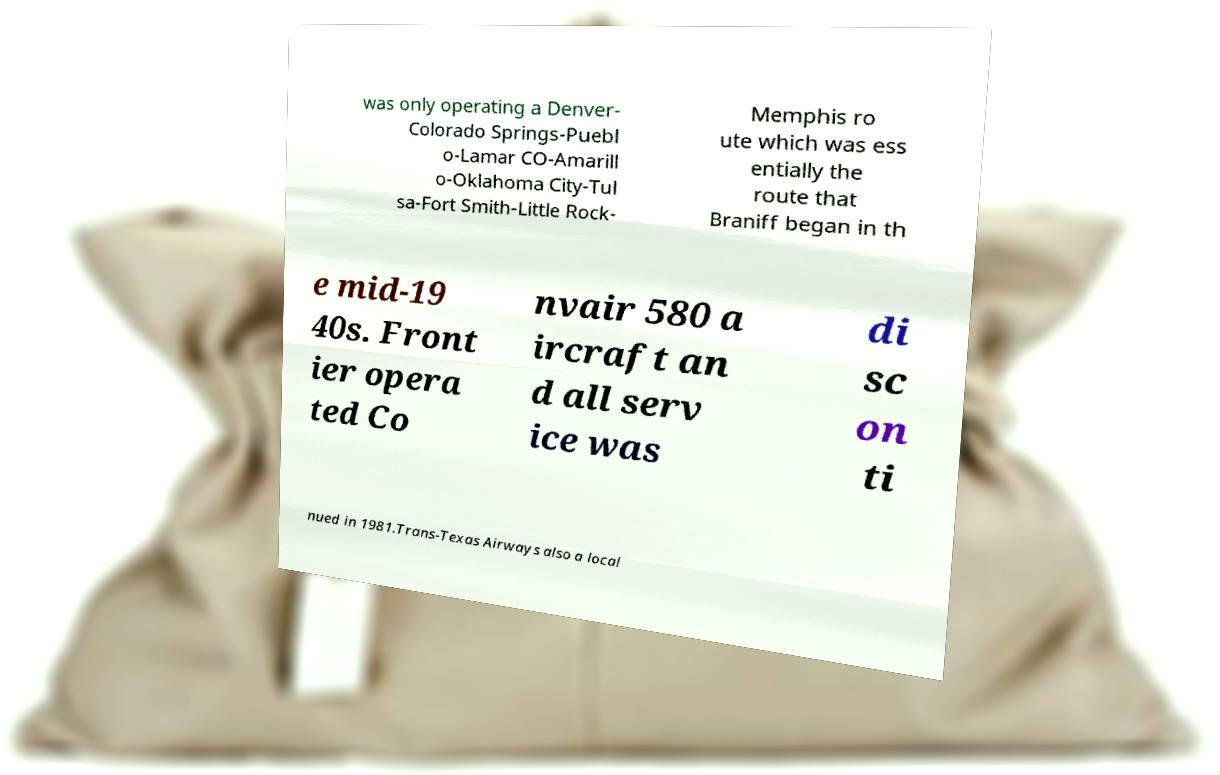There's text embedded in this image that I need extracted. Can you transcribe it verbatim? was only operating a Denver- Colorado Springs-Puebl o-Lamar CO-Amarill o-Oklahoma City-Tul sa-Fort Smith-Little Rock- Memphis ro ute which was ess entially the route that Braniff began in th e mid-19 40s. Front ier opera ted Co nvair 580 a ircraft an d all serv ice was di sc on ti nued in 1981.Trans-Texas Airways also a local 